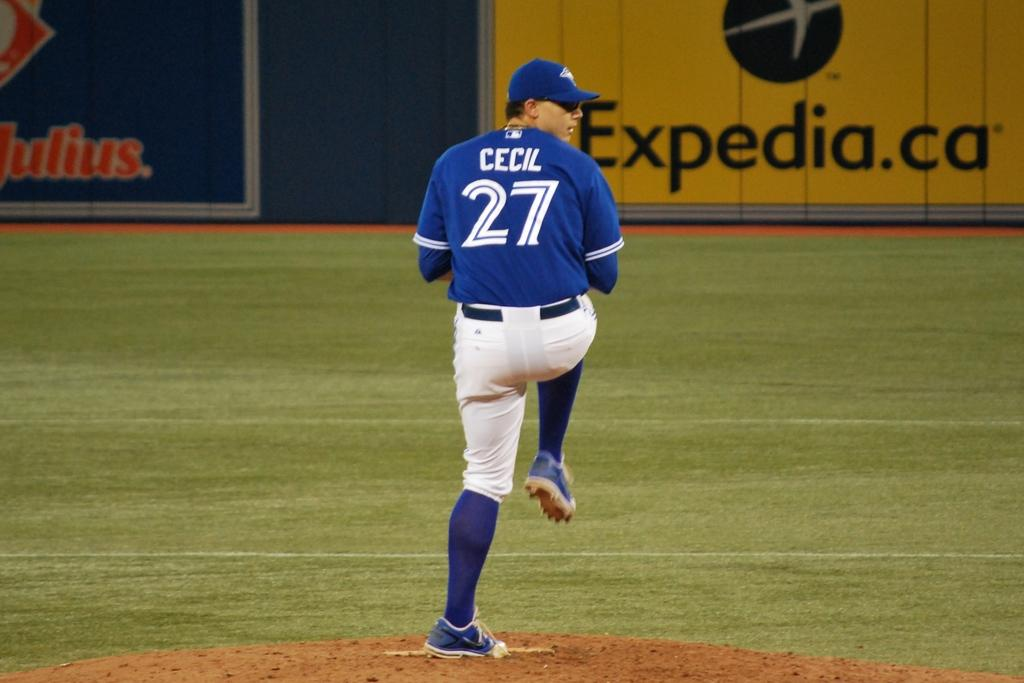<image>
Share a concise interpretation of the image provided. a baseball pitcher number 27 on the mound ready to throw 